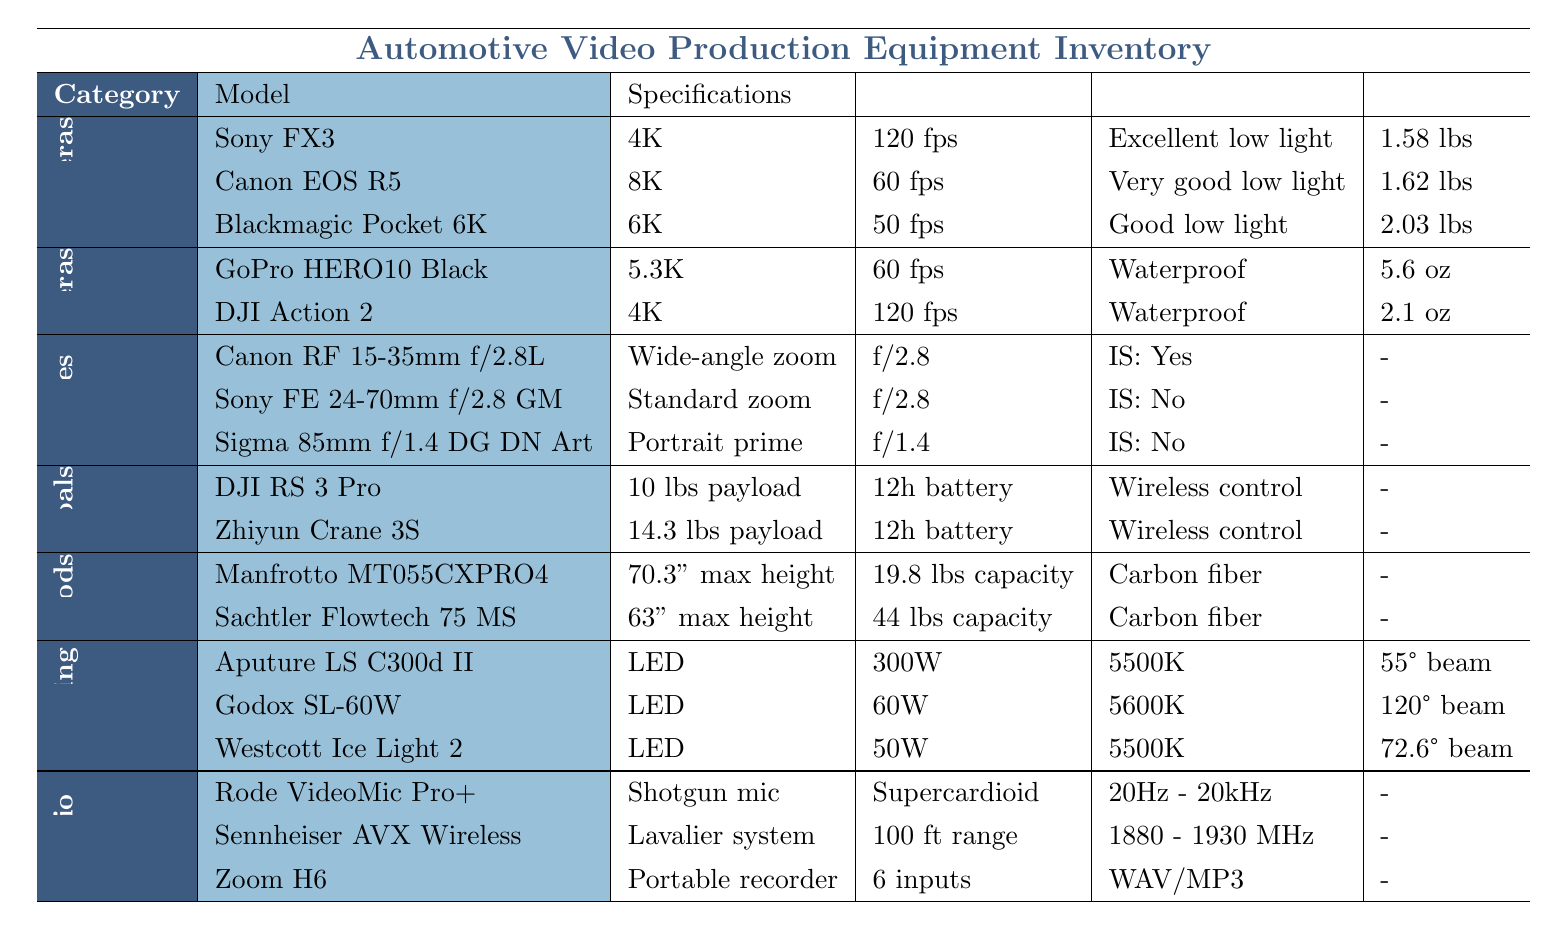What is the maximum resolution of the primary cameras? The primary cameras listed are the Sony FX3 (4K), Canon EOS R5 (8K), and Blackmagic Pocket Cinema Camera 6K (6K). Among these, the Canon EOS R5 has the highest resolution at 8K.
Answer: 8K Which action camera has the lowest weight? The action cameras listed are the GoPro HERO10 Black (5.6 oz) and the DJI Action 2 (2.1 oz). Comparing their weights, the DJI Action 2 is lighter at 2.1 oz.
Answer: DJI Action 2 Do the lenses include image stabilization? The table lists three lenses: Canon RF 15-35mm f/2.8L IS USM (Yes), Sony FE 24-70mm f/2.8 GM (No), and Sigma 85mm f/1.4 DG DN Art (No). Only the Canon RF 15-35mm lens has image stabilization.
Answer: No What is the combined maximum payload capacity of the gimbals? The gimbals listed are DJI RS 3 Pro (10 lbs) and Zhiyun Crane 3S (14.3 lbs). Adding their capacities gives 10 + 14.3 = 24.3 lbs.
Answer: 24.3 lbs Which lighting equipment has the highest power output? The lighting equipment includes Aputure LS C300d II (300W), Godox SL-60W (60W), and Westcott Ice Light 2 (50W). The Aputure LS C300d II has the highest power output of 300W.
Answer: Aputure LS C300d II How many total audio equipment items are listed? There are three types of audio equipment: Rode VideoMic Pro+, Sennheiser AVX Digital Wireless, and Zoom H6. Therefore, the total count of audio equipment items is three.
Answer: 3 Is there a tripod with a load capacity of 44 lbs? The tripods listed are Manfrotto MT055CXPRO4 (19.8 lbs) and Sachtler Flowtech 75 MS (44 lbs). Since the Sachtler Flowtech 75 MS has a load capacity of 44 lbs, the answer is yes.
Answer: Yes What is the difference in max height between the two tripods? The maximum height of the Manfrotto MT055CXPRO4 is 70.3 inches, and for the Sachtler Flowtech 75 MS, it is 63 inches. Thus, the difference is 70.3 - 63 = 7.3 inches.
Answer: 7.3 inches Which camera has the best low light performance based on the table? The primary cameras listed have different low light performances: Sony FX3 (Excellent), Canon EOS R5 (Very Good), and Blackmagic Pocket Cinema Camera 6K (Good). The Sony FX3 has the best low light performance described as excellent.
Answer: Sony FX3 What types of microphones are included in the audio equipment? The audio equipment includes a Rode VideoMic Pro+ (Shotgun microphone), Sennheiser AVX Digital Wireless (Wireless lavalier system), and Zoom H6 (Portable recorder). Thus, the microphones included are shotgun and wireless lavalier.
Answer: Shotgun and wireless lavalier 